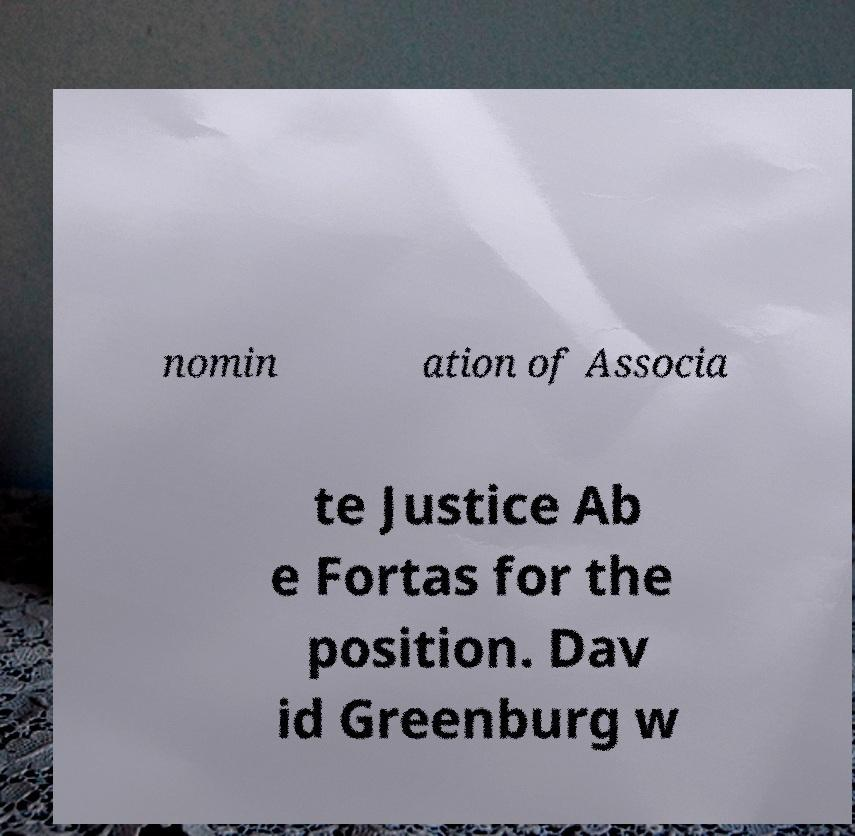There's text embedded in this image that I need extracted. Can you transcribe it verbatim? nomin ation of Associa te Justice Ab e Fortas for the position. Dav id Greenburg w 